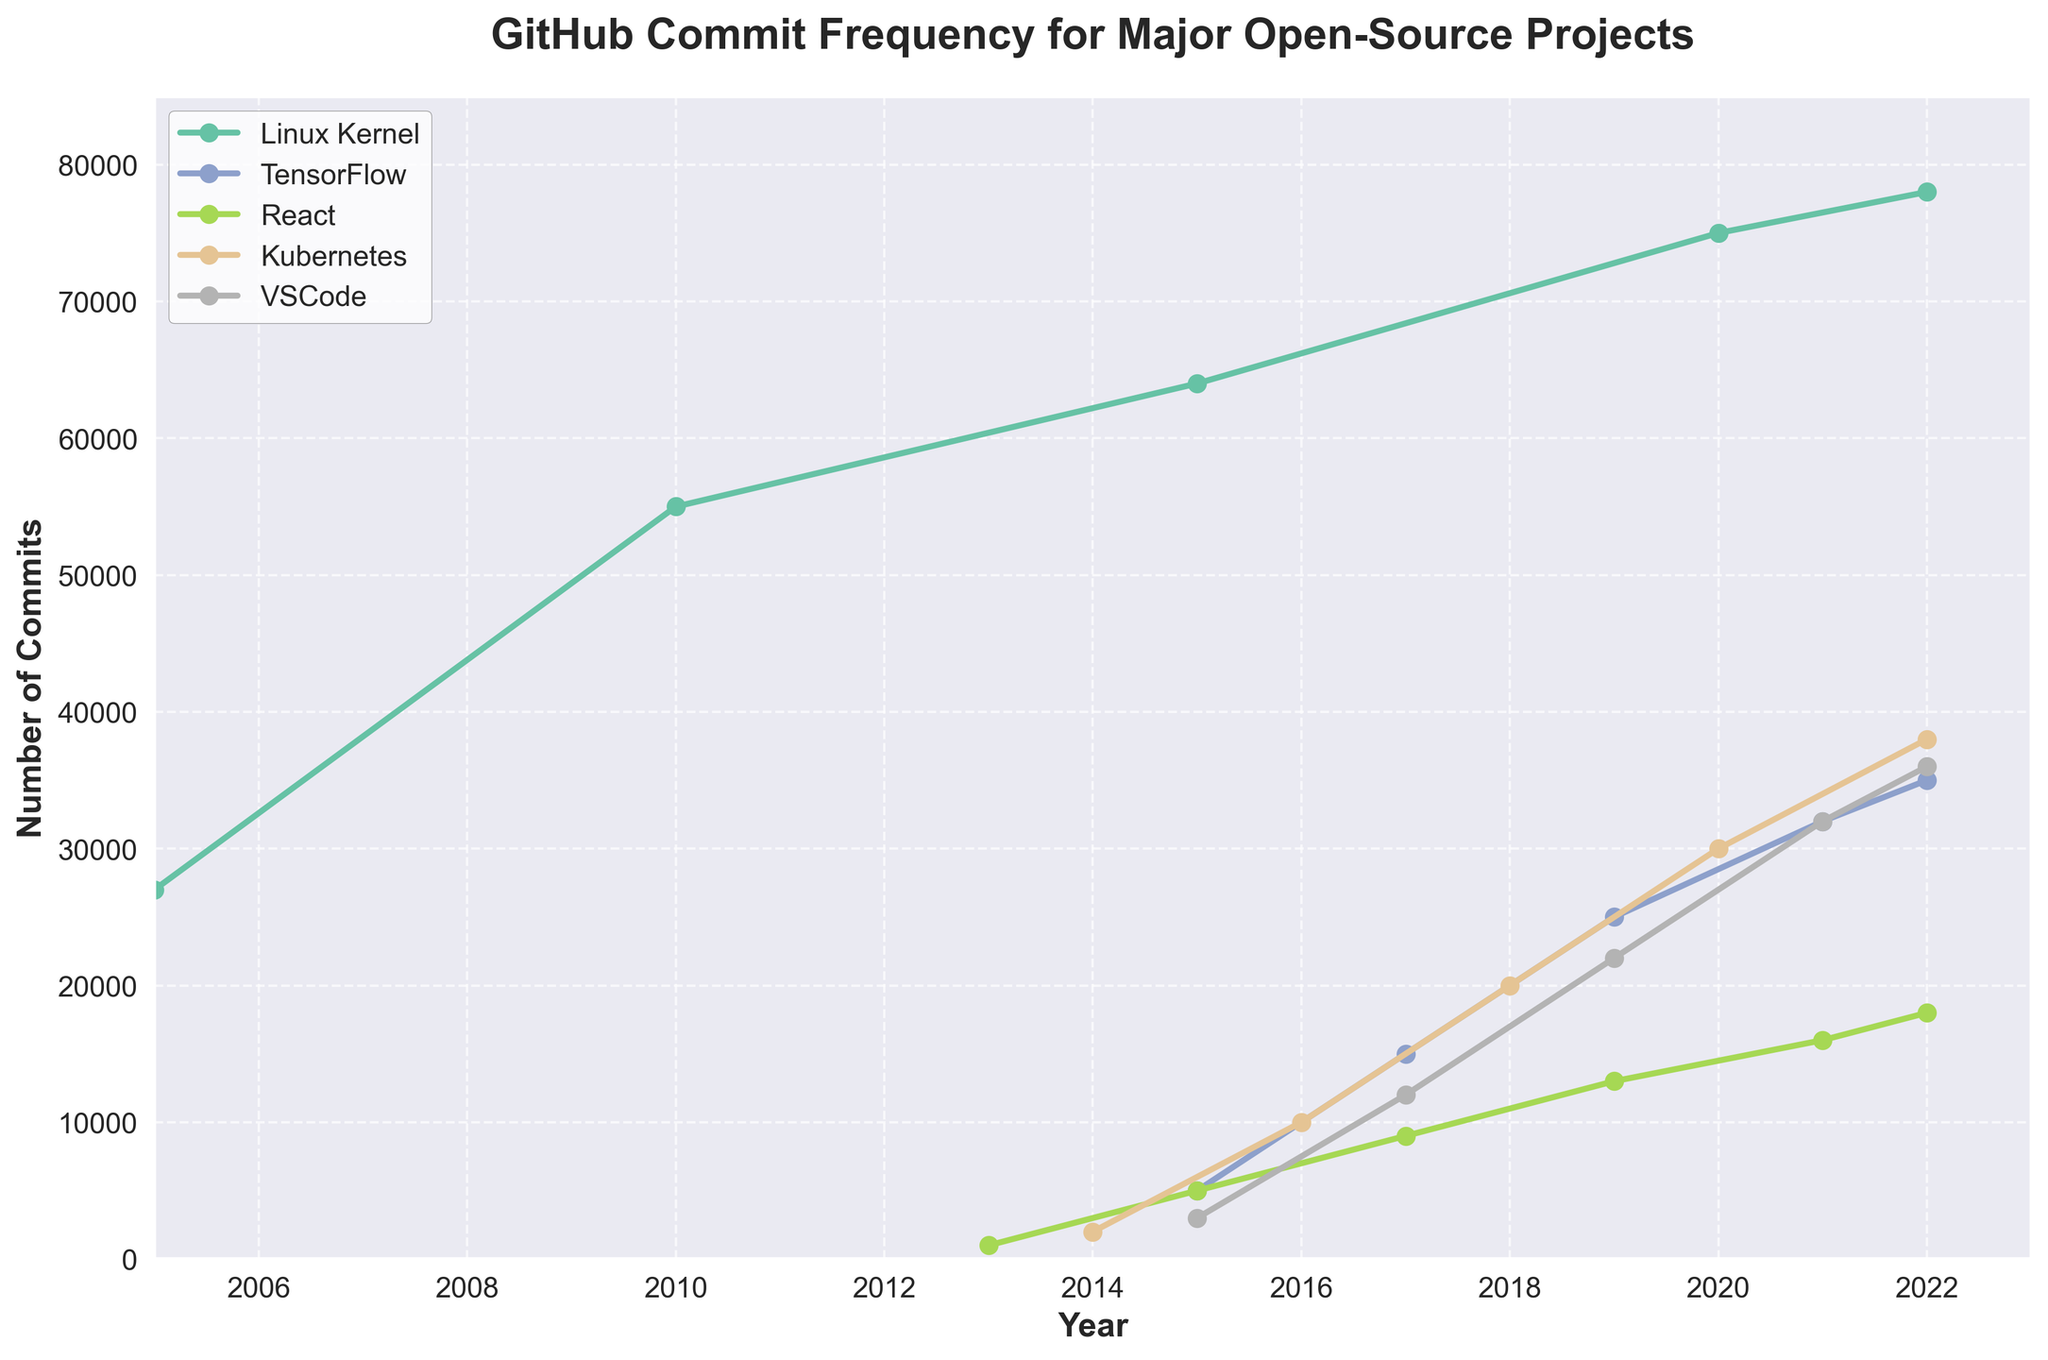Which project received the highest number of commits in 2022? Looking at the endpoints of each line in 2022 on the plot, we see Linux Kernel has the highest value, represented by the highest point on the y-axis among all projects.
Answer: Linux Kernel Between 2015 and 2020, did TensorFlow or VSCode have a larger increase in commits? For TensorFlow, the number of commits increased from 5000 in 2015 to 32000 in 2020. For VSCode, the number of commits increased from 3000 in 2015 to 32000 in 2020. Therefore, the increase is 27000 for TensorFlow and 29000 for VSCode.
Answer: VSCode How many commits did the Linux Kernel project gain from 2005 to 2022? From 2005 to 2022, the Linux Kernel's commits increased from 27000 to 78000. To find the gain, subtract the 2005 value from the 2022 value: 78000 - 27000 = 51000.
Answer: 51000 Which project exhibited the most significant growth in commits between its start year and 2022? By comparing the start year and 2022 commit counts for each project:
Linux Kernel: 27000 to 78000 (51000),
TensorFlow: 5000 to 35000 (30000),
React: 1000 to 18000 (17000),
Kubernetes: 2000 to 38000 (36000),
VSCode: 3000 to 36000 (33000). Linux Kernel has the highest growth at 51000.
Answer: Linux Kernel Which project showed a decrease in commits any year between 2005 and 2022? Evaluating the lines on the plot for any downturn, none of the project's commit lines show a decrease at any point across the years.
Answer: None In 2016, which project had the second-highest number of commits and how many? Looking at the plot for the year 2016, Kubernetes had 10000 commits, while the other projects had either fewer or more for that particular year.
Answer: Kubernetes, 10000 By how much did the number of commits in React increase from 2015 to 2019? From 2015 to 2019, React's commits increased from 5000 to 13000. Subtract the 2015 value from the 2019 value: 13000 - 5000 = 8000.
Answer: 8000 Which project had the least number of commits in its start year? Comparing the start points of all the projects' lines:
Linux Kernel: 27000,
TensorFlow: 5000,
React: 1000,
Kubernetes: 2000,
VSCode: 3000.
React has the lowest number.
Answer: React On average, how many commits were added to Kubernetes each year from 2014 to 2022? The number of commits for Kubernetes in respective years: 2014 (2000), 2016 (10000), 2018 (20000), 2020 (30000), 2022 (38000). To find the average, calculate the total increment (38000 - 2000 = 36000) and divide by the number of years (2022 - 2014 = 8): 36000 / 8 = 4500.
Answer: 4500 